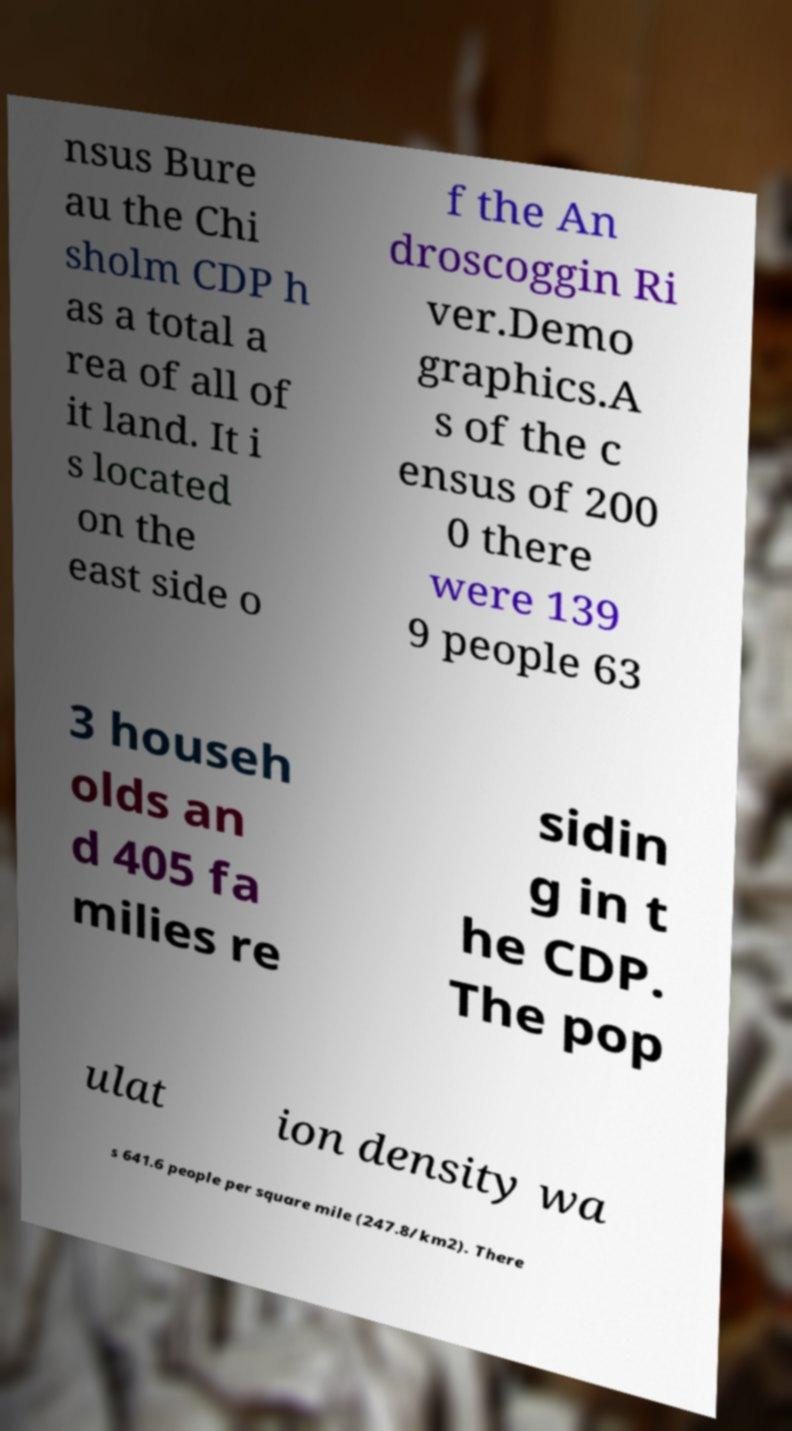Could you extract and type out the text from this image? nsus Bure au the Chi sholm CDP h as a total a rea of all of it land. It i s located on the east side o f the An droscoggin Ri ver.Demo graphics.A s of the c ensus of 200 0 there were 139 9 people 63 3 househ olds an d 405 fa milies re sidin g in t he CDP. The pop ulat ion density wa s 641.6 people per square mile (247.8/km2). There 